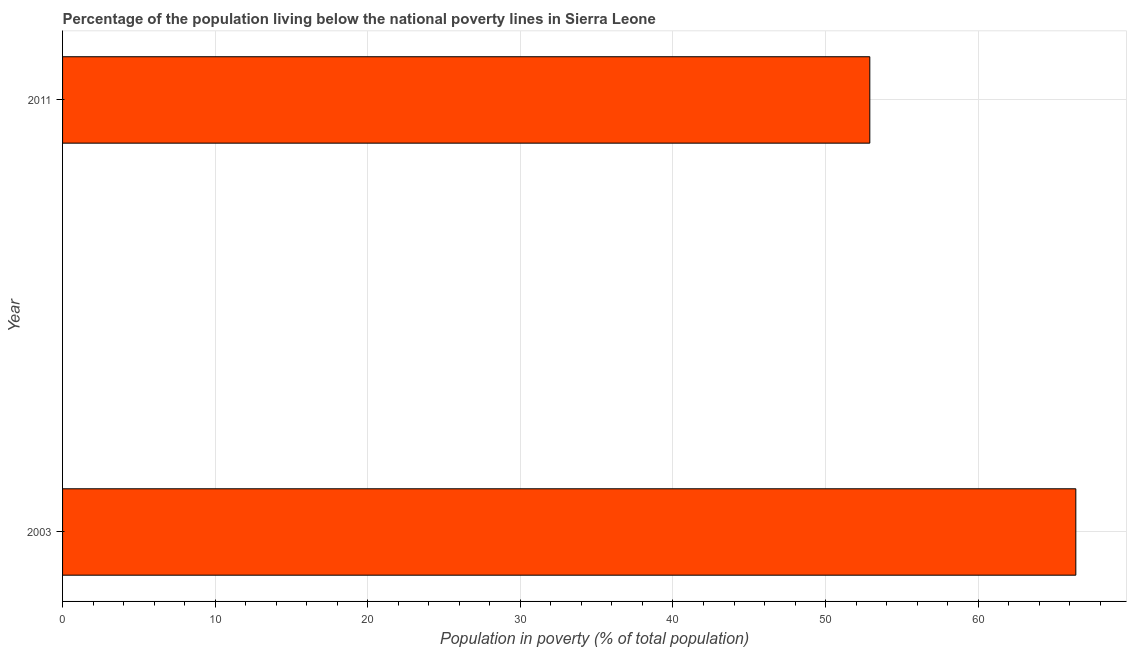What is the title of the graph?
Offer a terse response. Percentage of the population living below the national poverty lines in Sierra Leone. What is the label or title of the X-axis?
Provide a short and direct response. Population in poverty (% of total population). What is the label or title of the Y-axis?
Give a very brief answer. Year. What is the percentage of population living below poverty line in 2011?
Keep it short and to the point. 52.9. Across all years, what is the maximum percentage of population living below poverty line?
Ensure brevity in your answer.  66.4. Across all years, what is the minimum percentage of population living below poverty line?
Ensure brevity in your answer.  52.9. What is the sum of the percentage of population living below poverty line?
Your response must be concise. 119.3. What is the difference between the percentage of population living below poverty line in 2003 and 2011?
Keep it short and to the point. 13.5. What is the average percentage of population living below poverty line per year?
Keep it short and to the point. 59.65. What is the median percentage of population living below poverty line?
Your response must be concise. 59.65. Do a majority of the years between 2003 and 2011 (inclusive) have percentage of population living below poverty line greater than 40 %?
Your answer should be compact. Yes. What is the ratio of the percentage of population living below poverty line in 2003 to that in 2011?
Offer a very short reply. 1.25. In how many years, is the percentage of population living below poverty line greater than the average percentage of population living below poverty line taken over all years?
Give a very brief answer. 1. Are all the bars in the graph horizontal?
Ensure brevity in your answer.  Yes. What is the Population in poverty (% of total population) in 2003?
Your response must be concise. 66.4. What is the Population in poverty (% of total population) of 2011?
Offer a terse response. 52.9. What is the ratio of the Population in poverty (% of total population) in 2003 to that in 2011?
Your answer should be very brief. 1.25. 